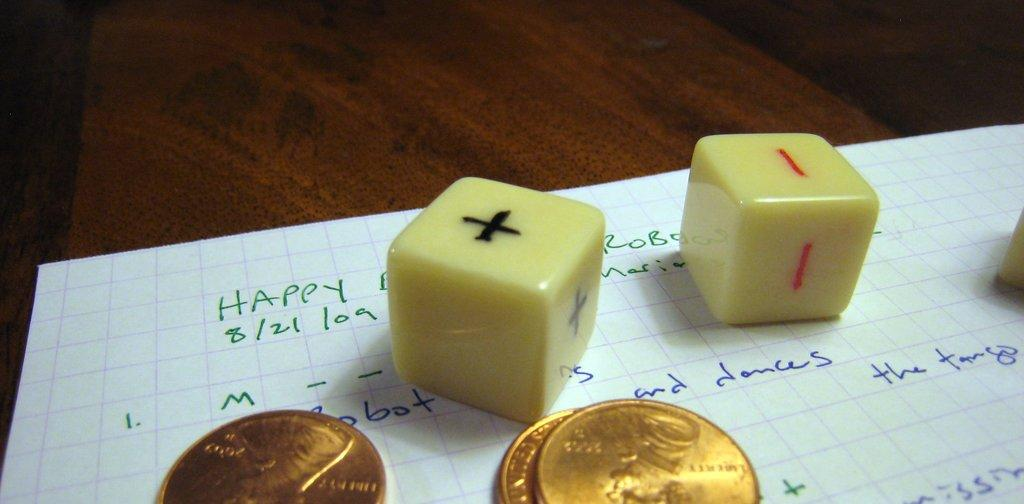What is the color of the paper in the image? The paper in the image is white. What type of objects are the golden color coins in the image? The golden color objects in the image are coins. What type of creature can be seen interacting with the coins in the image? There is no creature present in the image; it only features a white color paper and golden color coins. How many bikes are visible in the image? There are no bikes present in the image. 